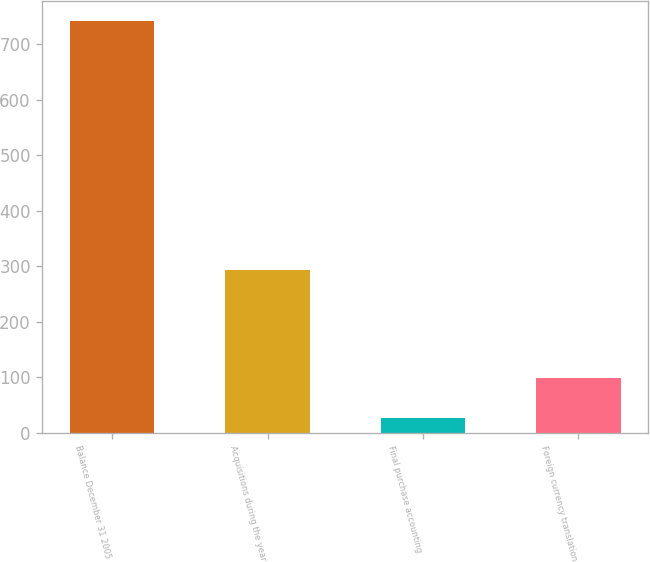Convert chart to OTSL. <chart><loc_0><loc_0><loc_500><loc_500><bar_chart><fcel>Balance December 31 2005<fcel>Acquisitions during the year<fcel>Final purchase accounting<fcel>Foreign currency translation<nl><fcel>740.9<fcel>292.6<fcel>26.8<fcel>98.21<nl></chart> 